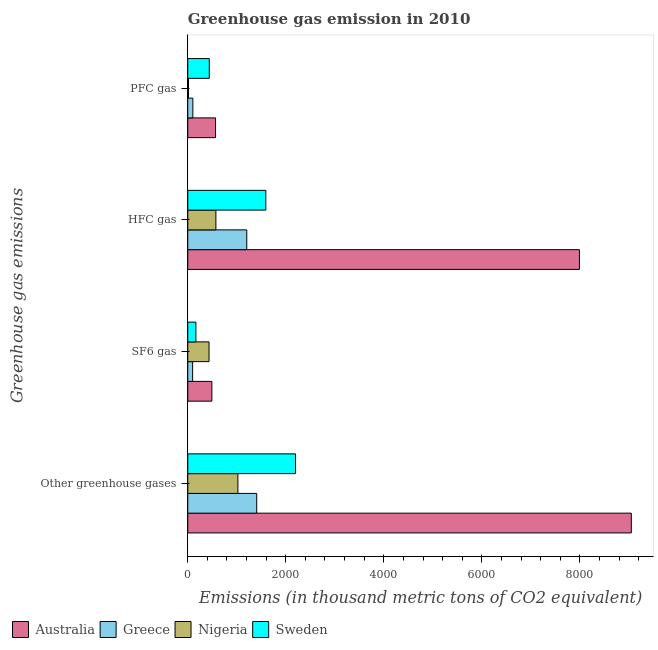How many groups of bars are there?
Your answer should be very brief. 4. How many bars are there on the 3rd tick from the bottom?
Offer a terse response. 4. What is the label of the 1st group of bars from the top?
Your answer should be compact. PFC gas. What is the emission of sf6 gas in Nigeria?
Make the answer very short. 434. Across all countries, what is the maximum emission of hfc gas?
Offer a very short reply. 7992. Across all countries, what is the minimum emission of sf6 gas?
Make the answer very short. 99. In which country was the emission of pfc gas maximum?
Provide a succinct answer. Australia. In which country was the emission of hfc gas minimum?
Ensure brevity in your answer.  Nigeria. What is the total emission of sf6 gas in the graph?
Offer a very short reply. 1191. What is the difference between the emission of hfc gas in Greece and that in Nigeria?
Give a very brief answer. 630. What is the difference between the emission of hfc gas in Nigeria and the emission of greenhouse gases in Australia?
Your answer should be very brief. -8477. What is the average emission of greenhouse gases per country?
Make the answer very short. 3419.75. What is the difference between the emission of sf6 gas and emission of hfc gas in Australia?
Your response must be concise. -7500. What is the ratio of the emission of hfc gas in Nigeria to that in Greece?
Your answer should be very brief. 0.48. Is the emission of hfc gas in Sweden less than that in Nigeria?
Ensure brevity in your answer.  No. Is the difference between the emission of greenhouse gases in Greece and Australia greater than the difference between the emission of pfc gas in Greece and Australia?
Your answer should be very brief. No. What is the difference between the highest and the second highest emission of sf6 gas?
Your answer should be very brief. 58. What is the difference between the highest and the lowest emission of hfc gas?
Provide a succinct answer. 7418. In how many countries, is the emission of greenhouse gases greater than the average emission of greenhouse gases taken over all countries?
Provide a short and direct response. 1. Is the sum of the emission of greenhouse gases in Australia and Sweden greater than the maximum emission of hfc gas across all countries?
Your response must be concise. Yes. Is it the case that in every country, the sum of the emission of pfc gas and emission of greenhouse gases is greater than the sum of emission of hfc gas and emission of sf6 gas?
Provide a short and direct response. Yes. Is it the case that in every country, the sum of the emission of greenhouse gases and emission of sf6 gas is greater than the emission of hfc gas?
Make the answer very short. Yes. How many bars are there?
Provide a succinct answer. 16. Does the graph contain any zero values?
Make the answer very short. No. Where does the legend appear in the graph?
Provide a succinct answer. Bottom left. How many legend labels are there?
Your answer should be very brief. 4. What is the title of the graph?
Give a very brief answer. Greenhouse gas emission in 2010. Does "United States" appear as one of the legend labels in the graph?
Your answer should be very brief. No. What is the label or title of the X-axis?
Offer a very short reply. Emissions (in thousand metric tons of CO2 equivalent). What is the label or title of the Y-axis?
Your answer should be compact. Greenhouse gas emissions. What is the Emissions (in thousand metric tons of CO2 equivalent) in Australia in Other greenhouse gases?
Your response must be concise. 9051. What is the Emissions (in thousand metric tons of CO2 equivalent) of Greece in Other greenhouse gases?
Offer a very short reply. 1407. What is the Emissions (in thousand metric tons of CO2 equivalent) of Nigeria in Other greenhouse gases?
Keep it short and to the point. 1023. What is the Emissions (in thousand metric tons of CO2 equivalent) in Sweden in Other greenhouse gases?
Give a very brief answer. 2198. What is the Emissions (in thousand metric tons of CO2 equivalent) in Australia in SF6 gas?
Provide a short and direct response. 492. What is the Emissions (in thousand metric tons of CO2 equivalent) in Nigeria in SF6 gas?
Your answer should be compact. 434. What is the Emissions (in thousand metric tons of CO2 equivalent) of Sweden in SF6 gas?
Provide a short and direct response. 166. What is the Emissions (in thousand metric tons of CO2 equivalent) in Australia in HFC gas?
Offer a very short reply. 7992. What is the Emissions (in thousand metric tons of CO2 equivalent) in Greece in HFC gas?
Ensure brevity in your answer.  1204. What is the Emissions (in thousand metric tons of CO2 equivalent) of Nigeria in HFC gas?
Your answer should be compact. 574. What is the Emissions (in thousand metric tons of CO2 equivalent) in Sweden in HFC gas?
Your answer should be compact. 1593. What is the Emissions (in thousand metric tons of CO2 equivalent) of Australia in PFC gas?
Offer a terse response. 567. What is the Emissions (in thousand metric tons of CO2 equivalent) in Greece in PFC gas?
Keep it short and to the point. 104. What is the Emissions (in thousand metric tons of CO2 equivalent) in Nigeria in PFC gas?
Offer a very short reply. 15. What is the Emissions (in thousand metric tons of CO2 equivalent) of Sweden in PFC gas?
Your response must be concise. 439. Across all Greenhouse gas emissions, what is the maximum Emissions (in thousand metric tons of CO2 equivalent) of Australia?
Give a very brief answer. 9051. Across all Greenhouse gas emissions, what is the maximum Emissions (in thousand metric tons of CO2 equivalent) of Greece?
Offer a terse response. 1407. Across all Greenhouse gas emissions, what is the maximum Emissions (in thousand metric tons of CO2 equivalent) of Nigeria?
Your answer should be very brief. 1023. Across all Greenhouse gas emissions, what is the maximum Emissions (in thousand metric tons of CO2 equivalent) in Sweden?
Ensure brevity in your answer.  2198. Across all Greenhouse gas emissions, what is the minimum Emissions (in thousand metric tons of CO2 equivalent) in Australia?
Your answer should be compact. 492. Across all Greenhouse gas emissions, what is the minimum Emissions (in thousand metric tons of CO2 equivalent) of Nigeria?
Keep it short and to the point. 15. Across all Greenhouse gas emissions, what is the minimum Emissions (in thousand metric tons of CO2 equivalent) in Sweden?
Your answer should be very brief. 166. What is the total Emissions (in thousand metric tons of CO2 equivalent) of Australia in the graph?
Give a very brief answer. 1.81e+04. What is the total Emissions (in thousand metric tons of CO2 equivalent) in Greece in the graph?
Offer a very short reply. 2814. What is the total Emissions (in thousand metric tons of CO2 equivalent) in Nigeria in the graph?
Make the answer very short. 2046. What is the total Emissions (in thousand metric tons of CO2 equivalent) in Sweden in the graph?
Make the answer very short. 4396. What is the difference between the Emissions (in thousand metric tons of CO2 equivalent) in Australia in Other greenhouse gases and that in SF6 gas?
Provide a succinct answer. 8559. What is the difference between the Emissions (in thousand metric tons of CO2 equivalent) of Greece in Other greenhouse gases and that in SF6 gas?
Keep it short and to the point. 1308. What is the difference between the Emissions (in thousand metric tons of CO2 equivalent) of Nigeria in Other greenhouse gases and that in SF6 gas?
Give a very brief answer. 589. What is the difference between the Emissions (in thousand metric tons of CO2 equivalent) in Sweden in Other greenhouse gases and that in SF6 gas?
Offer a very short reply. 2032. What is the difference between the Emissions (in thousand metric tons of CO2 equivalent) in Australia in Other greenhouse gases and that in HFC gas?
Ensure brevity in your answer.  1059. What is the difference between the Emissions (in thousand metric tons of CO2 equivalent) in Greece in Other greenhouse gases and that in HFC gas?
Your answer should be compact. 203. What is the difference between the Emissions (in thousand metric tons of CO2 equivalent) of Nigeria in Other greenhouse gases and that in HFC gas?
Ensure brevity in your answer.  449. What is the difference between the Emissions (in thousand metric tons of CO2 equivalent) in Sweden in Other greenhouse gases and that in HFC gas?
Your response must be concise. 605. What is the difference between the Emissions (in thousand metric tons of CO2 equivalent) in Australia in Other greenhouse gases and that in PFC gas?
Make the answer very short. 8484. What is the difference between the Emissions (in thousand metric tons of CO2 equivalent) in Greece in Other greenhouse gases and that in PFC gas?
Provide a succinct answer. 1303. What is the difference between the Emissions (in thousand metric tons of CO2 equivalent) of Nigeria in Other greenhouse gases and that in PFC gas?
Offer a terse response. 1008. What is the difference between the Emissions (in thousand metric tons of CO2 equivalent) in Sweden in Other greenhouse gases and that in PFC gas?
Your response must be concise. 1759. What is the difference between the Emissions (in thousand metric tons of CO2 equivalent) of Australia in SF6 gas and that in HFC gas?
Your answer should be compact. -7500. What is the difference between the Emissions (in thousand metric tons of CO2 equivalent) in Greece in SF6 gas and that in HFC gas?
Make the answer very short. -1105. What is the difference between the Emissions (in thousand metric tons of CO2 equivalent) of Nigeria in SF6 gas and that in HFC gas?
Make the answer very short. -140. What is the difference between the Emissions (in thousand metric tons of CO2 equivalent) in Sweden in SF6 gas and that in HFC gas?
Offer a terse response. -1427. What is the difference between the Emissions (in thousand metric tons of CO2 equivalent) in Australia in SF6 gas and that in PFC gas?
Offer a very short reply. -75. What is the difference between the Emissions (in thousand metric tons of CO2 equivalent) of Nigeria in SF6 gas and that in PFC gas?
Provide a short and direct response. 419. What is the difference between the Emissions (in thousand metric tons of CO2 equivalent) of Sweden in SF6 gas and that in PFC gas?
Your answer should be compact. -273. What is the difference between the Emissions (in thousand metric tons of CO2 equivalent) of Australia in HFC gas and that in PFC gas?
Provide a succinct answer. 7425. What is the difference between the Emissions (in thousand metric tons of CO2 equivalent) in Greece in HFC gas and that in PFC gas?
Offer a very short reply. 1100. What is the difference between the Emissions (in thousand metric tons of CO2 equivalent) of Nigeria in HFC gas and that in PFC gas?
Offer a terse response. 559. What is the difference between the Emissions (in thousand metric tons of CO2 equivalent) in Sweden in HFC gas and that in PFC gas?
Your answer should be very brief. 1154. What is the difference between the Emissions (in thousand metric tons of CO2 equivalent) in Australia in Other greenhouse gases and the Emissions (in thousand metric tons of CO2 equivalent) in Greece in SF6 gas?
Your answer should be very brief. 8952. What is the difference between the Emissions (in thousand metric tons of CO2 equivalent) in Australia in Other greenhouse gases and the Emissions (in thousand metric tons of CO2 equivalent) in Nigeria in SF6 gas?
Give a very brief answer. 8617. What is the difference between the Emissions (in thousand metric tons of CO2 equivalent) in Australia in Other greenhouse gases and the Emissions (in thousand metric tons of CO2 equivalent) in Sweden in SF6 gas?
Keep it short and to the point. 8885. What is the difference between the Emissions (in thousand metric tons of CO2 equivalent) of Greece in Other greenhouse gases and the Emissions (in thousand metric tons of CO2 equivalent) of Nigeria in SF6 gas?
Make the answer very short. 973. What is the difference between the Emissions (in thousand metric tons of CO2 equivalent) in Greece in Other greenhouse gases and the Emissions (in thousand metric tons of CO2 equivalent) in Sweden in SF6 gas?
Offer a very short reply. 1241. What is the difference between the Emissions (in thousand metric tons of CO2 equivalent) in Nigeria in Other greenhouse gases and the Emissions (in thousand metric tons of CO2 equivalent) in Sweden in SF6 gas?
Your response must be concise. 857. What is the difference between the Emissions (in thousand metric tons of CO2 equivalent) of Australia in Other greenhouse gases and the Emissions (in thousand metric tons of CO2 equivalent) of Greece in HFC gas?
Offer a very short reply. 7847. What is the difference between the Emissions (in thousand metric tons of CO2 equivalent) in Australia in Other greenhouse gases and the Emissions (in thousand metric tons of CO2 equivalent) in Nigeria in HFC gas?
Make the answer very short. 8477. What is the difference between the Emissions (in thousand metric tons of CO2 equivalent) in Australia in Other greenhouse gases and the Emissions (in thousand metric tons of CO2 equivalent) in Sweden in HFC gas?
Keep it short and to the point. 7458. What is the difference between the Emissions (in thousand metric tons of CO2 equivalent) of Greece in Other greenhouse gases and the Emissions (in thousand metric tons of CO2 equivalent) of Nigeria in HFC gas?
Provide a short and direct response. 833. What is the difference between the Emissions (in thousand metric tons of CO2 equivalent) of Greece in Other greenhouse gases and the Emissions (in thousand metric tons of CO2 equivalent) of Sweden in HFC gas?
Provide a succinct answer. -186. What is the difference between the Emissions (in thousand metric tons of CO2 equivalent) in Nigeria in Other greenhouse gases and the Emissions (in thousand metric tons of CO2 equivalent) in Sweden in HFC gas?
Offer a very short reply. -570. What is the difference between the Emissions (in thousand metric tons of CO2 equivalent) of Australia in Other greenhouse gases and the Emissions (in thousand metric tons of CO2 equivalent) of Greece in PFC gas?
Your response must be concise. 8947. What is the difference between the Emissions (in thousand metric tons of CO2 equivalent) of Australia in Other greenhouse gases and the Emissions (in thousand metric tons of CO2 equivalent) of Nigeria in PFC gas?
Ensure brevity in your answer.  9036. What is the difference between the Emissions (in thousand metric tons of CO2 equivalent) in Australia in Other greenhouse gases and the Emissions (in thousand metric tons of CO2 equivalent) in Sweden in PFC gas?
Provide a short and direct response. 8612. What is the difference between the Emissions (in thousand metric tons of CO2 equivalent) of Greece in Other greenhouse gases and the Emissions (in thousand metric tons of CO2 equivalent) of Nigeria in PFC gas?
Provide a short and direct response. 1392. What is the difference between the Emissions (in thousand metric tons of CO2 equivalent) of Greece in Other greenhouse gases and the Emissions (in thousand metric tons of CO2 equivalent) of Sweden in PFC gas?
Ensure brevity in your answer.  968. What is the difference between the Emissions (in thousand metric tons of CO2 equivalent) in Nigeria in Other greenhouse gases and the Emissions (in thousand metric tons of CO2 equivalent) in Sweden in PFC gas?
Give a very brief answer. 584. What is the difference between the Emissions (in thousand metric tons of CO2 equivalent) in Australia in SF6 gas and the Emissions (in thousand metric tons of CO2 equivalent) in Greece in HFC gas?
Provide a succinct answer. -712. What is the difference between the Emissions (in thousand metric tons of CO2 equivalent) of Australia in SF6 gas and the Emissions (in thousand metric tons of CO2 equivalent) of Nigeria in HFC gas?
Your answer should be very brief. -82. What is the difference between the Emissions (in thousand metric tons of CO2 equivalent) in Australia in SF6 gas and the Emissions (in thousand metric tons of CO2 equivalent) in Sweden in HFC gas?
Your answer should be very brief. -1101. What is the difference between the Emissions (in thousand metric tons of CO2 equivalent) of Greece in SF6 gas and the Emissions (in thousand metric tons of CO2 equivalent) of Nigeria in HFC gas?
Make the answer very short. -475. What is the difference between the Emissions (in thousand metric tons of CO2 equivalent) in Greece in SF6 gas and the Emissions (in thousand metric tons of CO2 equivalent) in Sweden in HFC gas?
Your answer should be compact. -1494. What is the difference between the Emissions (in thousand metric tons of CO2 equivalent) in Nigeria in SF6 gas and the Emissions (in thousand metric tons of CO2 equivalent) in Sweden in HFC gas?
Your answer should be very brief. -1159. What is the difference between the Emissions (in thousand metric tons of CO2 equivalent) of Australia in SF6 gas and the Emissions (in thousand metric tons of CO2 equivalent) of Greece in PFC gas?
Offer a terse response. 388. What is the difference between the Emissions (in thousand metric tons of CO2 equivalent) of Australia in SF6 gas and the Emissions (in thousand metric tons of CO2 equivalent) of Nigeria in PFC gas?
Your answer should be compact. 477. What is the difference between the Emissions (in thousand metric tons of CO2 equivalent) in Greece in SF6 gas and the Emissions (in thousand metric tons of CO2 equivalent) in Nigeria in PFC gas?
Make the answer very short. 84. What is the difference between the Emissions (in thousand metric tons of CO2 equivalent) in Greece in SF6 gas and the Emissions (in thousand metric tons of CO2 equivalent) in Sweden in PFC gas?
Keep it short and to the point. -340. What is the difference between the Emissions (in thousand metric tons of CO2 equivalent) in Nigeria in SF6 gas and the Emissions (in thousand metric tons of CO2 equivalent) in Sweden in PFC gas?
Your response must be concise. -5. What is the difference between the Emissions (in thousand metric tons of CO2 equivalent) in Australia in HFC gas and the Emissions (in thousand metric tons of CO2 equivalent) in Greece in PFC gas?
Provide a short and direct response. 7888. What is the difference between the Emissions (in thousand metric tons of CO2 equivalent) of Australia in HFC gas and the Emissions (in thousand metric tons of CO2 equivalent) of Nigeria in PFC gas?
Ensure brevity in your answer.  7977. What is the difference between the Emissions (in thousand metric tons of CO2 equivalent) of Australia in HFC gas and the Emissions (in thousand metric tons of CO2 equivalent) of Sweden in PFC gas?
Your response must be concise. 7553. What is the difference between the Emissions (in thousand metric tons of CO2 equivalent) of Greece in HFC gas and the Emissions (in thousand metric tons of CO2 equivalent) of Nigeria in PFC gas?
Offer a very short reply. 1189. What is the difference between the Emissions (in thousand metric tons of CO2 equivalent) in Greece in HFC gas and the Emissions (in thousand metric tons of CO2 equivalent) in Sweden in PFC gas?
Your answer should be very brief. 765. What is the difference between the Emissions (in thousand metric tons of CO2 equivalent) in Nigeria in HFC gas and the Emissions (in thousand metric tons of CO2 equivalent) in Sweden in PFC gas?
Offer a very short reply. 135. What is the average Emissions (in thousand metric tons of CO2 equivalent) of Australia per Greenhouse gas emissions?
Provide a succinct answer. 4525.5. What is the average Emissions (in thousand metric tons of CO2 equivalent) in Greece per Greenhouse gas emissions?
Provide a succinct answer. 703.5. What is the average Emissions (in thousand metric tons of CO2 equivalent) of Nigeria per Greenhouse gas emissions?
Provide a short and direct response. 511.5. What is the average Emissions (in thousand metric tons of CO2 equivalent) of Sweden per Greenhouse gas emissions?
Your answer should be compact. 1099. What is the difference between the Emissions (in thousand metric tons of CO2 equivalent) in Australia and Emissions (in thousand metric tons of CO2 equivalent) in Greece in Other greenhouse gases?
Your response must be concise. 7644. What is the difference between the Emissions (in thousand metric tons of CO2 equivalent) of Australia and Emissions (in thousand metric tons of CO2 equivalent) of Nigeria in Other greenhouse gases?
Your answer should be very brief. 8028. What is the difference between the Emissions (in thousand metric tons of CO2 equivalent) in Australia and Emissions (in thousand metric tons of CO2 equivalent) in Sweden in Other greenhouse gases?
Provide a short and direct response. 6853. What is the difference between the Emissions (in thousand metric tons of CO2 equivalent) in Greece and Emissions (in thousand metric tons of CO2 equivalent) in Nigeria in Other greenhouse gases?
Make the answer very short. 384. What is the difference between the Emissions (in thousand metric tons of CO2 equivalent) in Greece and Emissions (in thousand metric tons of CO2 equivalent) in Sweden in Other greenhouse gases?
Make the answer very short. -791. What is the difference between the Emissions (in thousand metric tons of CO2 equivalent) in Nigeria and Emissions (in thousand metric tons of CO2 equivalent) in Sweden in Other greenhouse gases?
Your answer should be very brief. -1175. What is the difference between the Emissions (in thousand metric tons of CO2 equivalent) of Australia and Emissions (in thousand metric tons of CO2 equivalent) of Greece in SF6 gas?
Your response must be concise. 393. What is the difference between the Emissions (in thousand metric tons of CO2 equivalent) in Australia and Emissions (in thousand metric tons of CO2 equivalent) in Sweden in SF6 gas?
Ensure brevity in your answer.  326. What is the difference between the Emissions (in thousand metric tons of CO2 equivalent) of Greece and Emissions (in thousand metric tons of CO2 equivalent) of Nigeria in SF6 gas?
Make the answer very short. -335. What is the difference between the Emissions (in thousand metric tons of CO2 equivalent) in Greece and Emissions (in thousand metric tons of CO2 equivalent) in Sweden in SF6 gas?
Ensure brevity in your answer.  -67. What is the difference between the Emissions (in thousand metric tons of CO2 equivalent) of Nigeria and Emissions (in thousand metric tons of CO2 equivalent) of Sweden in SF6 gas?
Offer a terse response. 268. What is the difference between the Emissions (in thousand metric tons of CO2 equivalent) of Australia and Emissions (in thousand metric tons of CO2 equivalent) of Greece in HFC gas?
Offer a terse response. 6788. What is the difference between the Emissions (in thousand metric tons of CO2 equivalent) of Australia and Emissions (in thousand metric tons of CO2 equivalent) of Nigeria in HFC gas?
Give a very brief answer. 7418. What is the difference between the Emissions (in thousand metric tons of CO2 equivalent) in Australia and Emissions (in thousand metric tons of CO2 equivalent) in Sweden in HFC gas?
Provide a short and direct response. 6399. What is the difference between the Emissions (in thousand metric tons of CO2 equivalent) of Greece and Emissions (in thousand metric tons of CO2 equivalent) of Nigeria in HFC gas?
Provide a succinct answer. 630. What is the difference between the Emissions (in thousand metric tons of CO2 equivalent) of Greece and Emissions (in thousand metric tons of CO2 equivalent) of Sweden in HFC gas?
Provide a short and direct response. -389. What is the difference between the Emissions (in thousand metric tons of CO2 equivalent) in Nigeria and Emissions (in thousand metric tons of CO2 equivalent) in Sweden in HFC gas?
Provide a succinct answer. -1019. What is the difference between the Emissions (in thousand metric tons of CO2 equivalent) in Australia and Emissions (in thousand metric tons of CO2 equivalent) in Greece in PFC gas?
Your response must be concise. 463. What is the difference between the Emissions (in thousand metric tons of CO2 equivalent) in Australia and Emissions (in thousand metric tons of CO2 equivalent) in Nigeria in PFC gas?
Offer a very short reply. 552. What is the difference between the Emissions (in thousand metric tons of CO2 equivalent) in Australia and Emissions (in thousand metric tons of CO2 equivalent) in Sweden in PFC gas?
Provide a succinct answer. 128. What is the difference between the Emissions (in thousand metric tons of CO2 equivalent) in Greece and Emissions (in thousand metric tons of CO2 equivalent) in Nigeria in PFC gas?
Offer a terse response. 89. What is the difference between the Emissions (in thousand metric tons of CO2 equivalent) in Greece and Emissions (in thousand metric tons of CO2 equivalent) in Sweden in PFC gas?
Offer a terse response. -335. What is the difference between the Emissions (in thousand metric tons of CO2 equivalent) in Nigeria and Emissions (in thousand metric tons of CO2 equivalent) in Sweden in PFC gas?
Keep it short and to the point. -424. What is the ratio of the Emissions (in thousand metric tons of CO2 equivalent) in Australia in Other greenhouse gases to that in SF6 gas?
Offer a terse response. 18.4. What is the ratio of the Emissions (in thousand metric tons of CO2 equivalent) in Greece in Other greenhouse gases to that in SF6 gas?
Your response must be concise. 14.21. What is the ratio of the Emissions (in thousand metric tons of CO2 equivalent) of Nigeria in Other greenhouse gases to that in SF6 gas?
Offer a very short reply. 2.36. What is the ratio of the Emissions (in thousand metric tons of CO2 equivalent) in Sweden in Other greenhouse gases to that in SF6 gas?
Provide a short and direct response. 13.24. What is the ratio of the Emissions (in thousand metric tons of CO2 equivalent) in Australia in Other greenhouse gases to that in HFC gas?
Ensure brevity in your answer.  1.13. What is the ratio of the Emissions (in thousand metric tons of CO2 equivalent) in Greece in Other greenhouse gases to that in HFC gas?
Make the answer very short. 1.17. What is the ratio of the Emissions (in thousand metric tons of CO2 equivalent) of Nigeria in Other greenhouse gases to that in HFC gas?
Provide a succinct answer. 1.78. What is the ratio of the Emissions (in thousand metric tons of CO2 equivalent) of Sweden in Other greenhouse gases to that in HFC gas?
Provide a succinct answer. 1.38. What is the ratio of the Emissions (in thousand metric tons of CO2 equivalent) of Australia in Other greenhouse gases to that in PFC gas?
Provide a short and direct response. 15.96. What is the ratio of the Emissions (in thousand metric tons of CO2 equivalent) in Greece in Other greenhouse gases to that in PFC gas?
Ensure brevity in your answer.  13.53. What is the ratio of the Emissions (in thousand metric tons of CO2 equivalent) in Nigeria in Other greenhouse gases to that in PFC gas?
Give a very brief answer. 68.2. What is the ratio of the Emissions (in thousand metric tons of CO2 equivalent) in Sweden in Other greenhouse gases to that in PFC gas?
Offer a terse response. 5.01. What is the ratio of the Emissions (in thousand metric tons of CO2 equivalent) of Australia in SF6 gas to that in HFC gas?
Ensure brevity in your answer.  0.06. What is the ratio of the Emissions (in thousand metric tons of CO2 equivalent) in Greece in SF6 gas to that in HFC gas?
Keep it short and to the point. 0.08. What is the ratio of the Emissions (in thousand metric tons of CO2 equivalent) of Nigeria in SF6 gas to that in HFC gas?
Offer a terse response. 0.76. What is the ratio of the Emissions (in thousand metric tons of CO2 equivalent) in Sweden in SF6 gas to that in HFC gas?
Provide a short and direct response. 0.1. What is the ratio of the Emissions (in thousand metric tons of CO2 equivalent) in Australia in SF6 gas to that in PFC gas?
Offer a very short reply. 0.87. What is the ratio of the Emissions (in thousand metric tons of CO2 equivalent) in Greece in SF6 gas to that in PFC gas?
Provide a short and direct response. 0.95. What is the ratio of the Emissions (in thousand metric tons of CO2 equivalent) in Nigeria in SF6 gas to that in PFC gas?
Keep it short and to the point. 28.93. What is the ratio of the Emissions (in thousand metric tons of CO2 equivalent) in Sweden in SF6 gas to that in PFC gas?
Make the answer very short. 0.38. What is the ratio of the Emissions (in thousand metric tons of CO2 equivalent) in Australia in HFC gas to that in PFC gas?
Offer a very short reply. 14.1. What is the ratio of the Emissions (in thousand metric tons of CO2 equivalent) in Greece in HFC gas to that in PFC gas?
Your answer should be very brief. 11.58. What is the ratio of the Emissions (in thousand metric tons of CO2 equivalent) of Nigeria in HFC gas to that in PFC gas?
Keep it short and to the point. 38.27. What is the ratio of the Emissions (in thousand metric tons of CO2 equivalent) of Sweden in HFC gas to that in PFC gas?
Offer a terse response. 3.63. What is the difference between the highest and the second highest Emissions (in thousand metric tons of CO2 equivalent) in Australia?
Your answer should be compact. 1059. What is the difference between the highest and the second highest Emissions (in thousand metric tons of CO2 equivalent) of Greece?
Offer a very short reply. 203. What is the difference between the highest and the second highest Emissions (in thousand metric tons of CO2 equivalent) in Nigeria?
Your answer should be compact. 449. What is the difference between the highest and the second highest Emissions (in thousand metric tons of CO2 equivalent) of Sweden?
Offer a very short reply. 605. What is the difference between the highest and the lowest Emissions (in thousand metric tons of CO2 equivalent) in Australia?
Your response must be concise. 8559. What is the difference between the highest and the lowest Emissions (in thousand metric tons of CO2 equivalent) in Greece?
Offer a terse response. 1308. What is the difference between the highest and the lowest Emissions (in thousand metric tons of CO2 equivalent) in Nigeria?
Your response must be concise. 1008. What is the difference between the highest and the lowest Emissions (in thousand metric tons of CO2 equivalent) of Sweden?
Your response must be concise. 2032. 